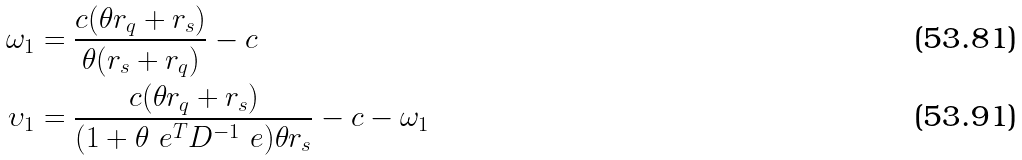Convert formula to latex. <formula><loc_0><loc_0><loc_500><loc_500>\omega _ { 1 } & = \frac { c ( \theta r _ { q } + r _ { s } ) } { \theta ( r _ { s } + r _ { q } ) } - c \\ \upsilon _ { 1 } & = \frac { c ( \theta r _ { q } + r _ { s } ) } { ( 1 + \theta \ e ^ { T } D ^ { - 1 } \ e ) \theta r _ { s } } - c - \omega _ { 1 }</formula> 